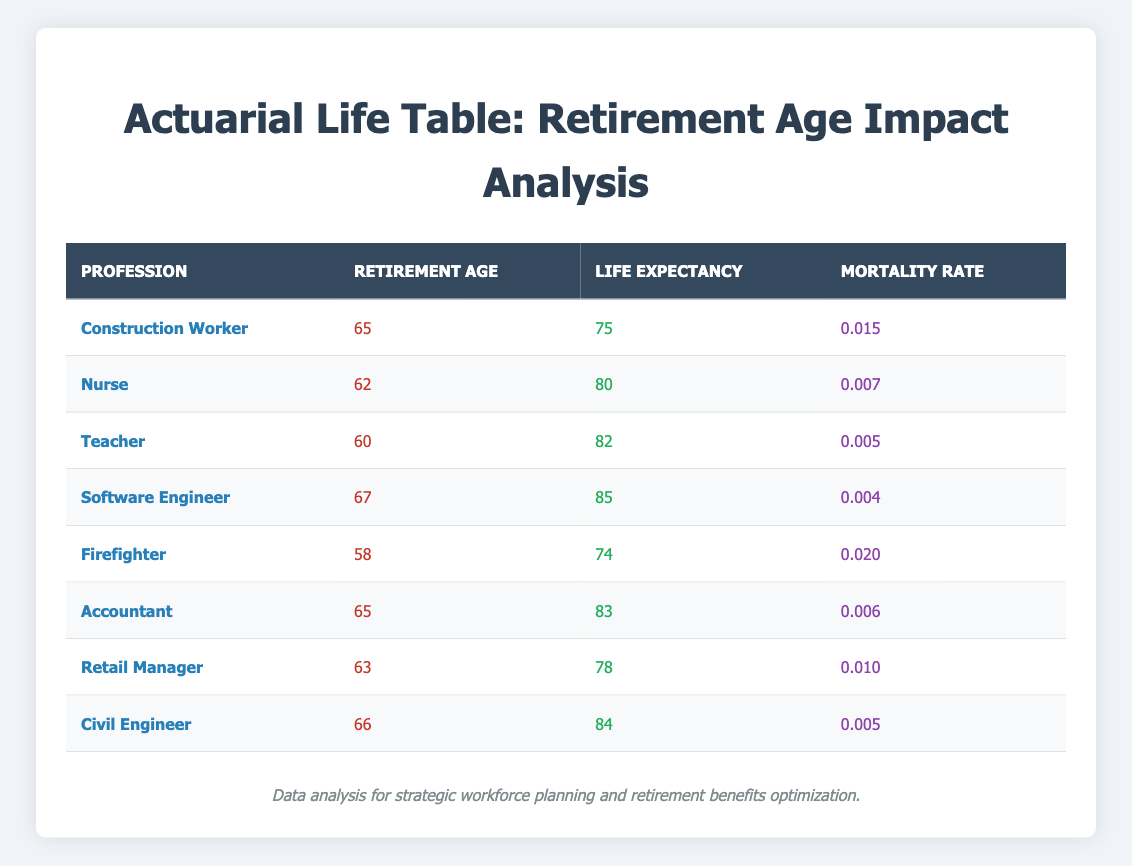What's the retirement age for a Software Engineer? According to the table, the retirement age for a Software Engineer is listed in the "Retirement Age" column next to that profession. It shows 67.
Answer: 67 Which profession has the highest life expectancy? By examining the "Life Expectancy" column, we can identify which profession has the highest value. The Software Engineer has a life expectancy of 85, which is the highest among all listed professions.
Answer: Software Engineer Is the mortality rate for Teachers higher than that for Nurses? The mortality rates for Teachers and Nurses can be found in the "Mortality Rate" column: Teachers have a rate of 0.005 and Nurses have a rate of 0.007. Since 0.007 is greater than 0.005, the statement is true.
Answer: Yes What is the average retirement age of all professions listed? Adding the retirement ages (65 + 62 + 60 + 67 + 58 + 65 + 63 + 66) gives a total of 466. There are 8 professions, so the average is 466 divided by 8, which equals 58.25.
Answer: 58.25 Is the life expectancy of a Construction Worker greater than the average of all listed professions? First, calculate the average life expectancy: (75 + 80 + 82 + 85 + 74 + 83 + 78 + 84) = 80.875. The life expectancy for a Construction Worker is 75, which is less than 80.875.
Answer: No What is the difference in life expectancy between Firefighters and Software Engineers? The life expectancy for Firefighters is 74, and for Software Engineers, it is 85. Finding the difference, 85 - 74 = 11.
Answer: 11 For which profession is the mortality rate lowest and what is that rate? The lowest mortality rate can be seen in the "Mortality Rate" column, where the Software Engineer has a rate of 0.004. Therefore, the profession with the lowest mortality rate is Software Engineer.
Answer: Software Engineer, 0.004 How many professions have a retirement age below 65? By reviewing the "Retirement Age" column, we can see that Firefighter (58) and Teacher (60) are less than 65. So there are 2 professions.
Answer: 2 